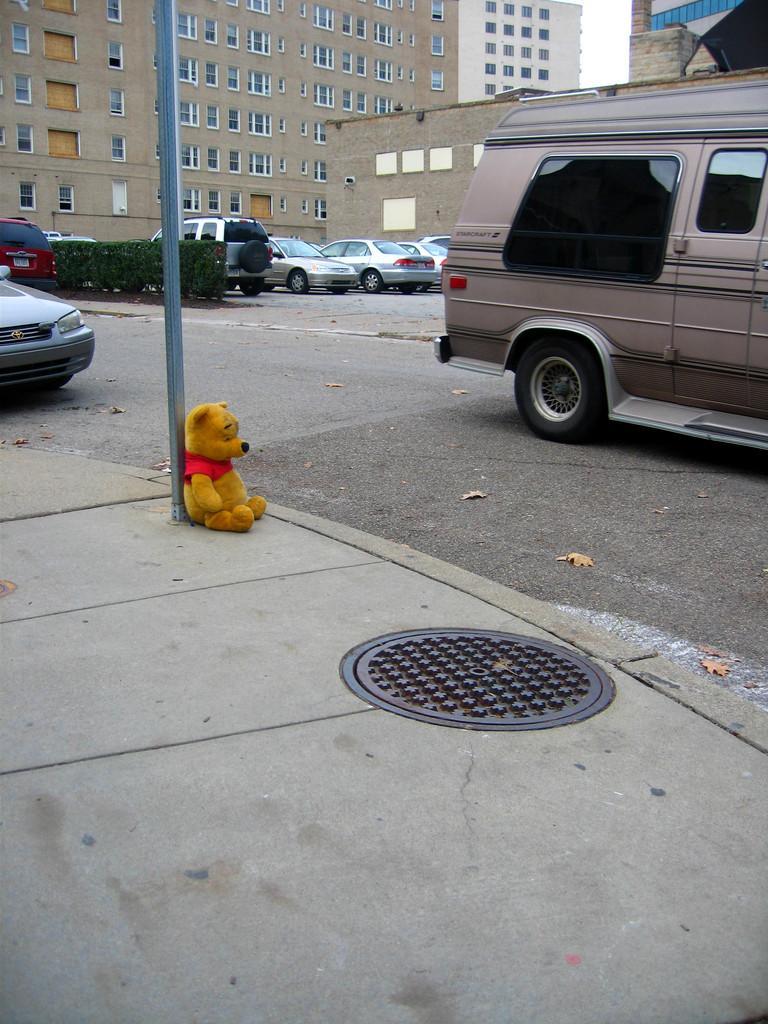Describe this image in one or two sentences. In this picture there is a teddy bear on the left side of the image and there are cars and buildings at the top side of the image. 